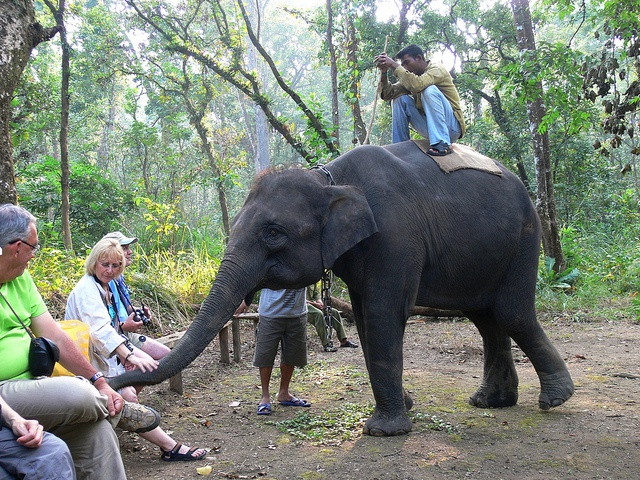Describe the objects in this image and their specific colors. I can see elephant in gray and black tones, people in gray, black, darkgray, and lightgray tones, people in gray, darkgray, and lightblue tones, people in gray, lavender, and darkgray tones, and people in gray, black, and maroon tones in this image. 